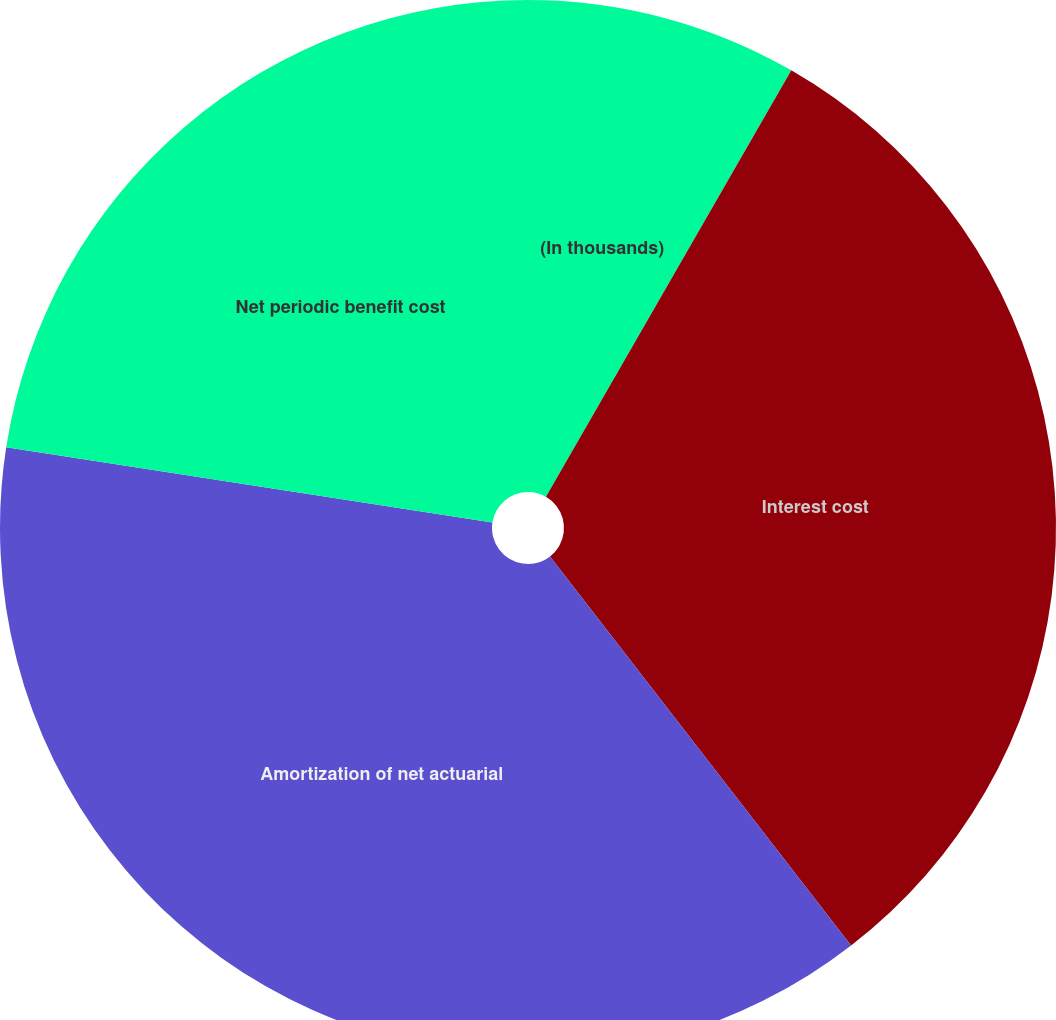Convert chart to OTSL. <chart><loc_0><loc_0><loc_500><loc_500><pie_chart><fcel>(In thousands)<fcel>Interest cost<fcel>Amortization of net actuarial<fcel>Net periodic benefit cost<nl><fcel>8.31%<fcel>31.21%<fcel>37.92%<fcel>22.56%<nl></chart> 